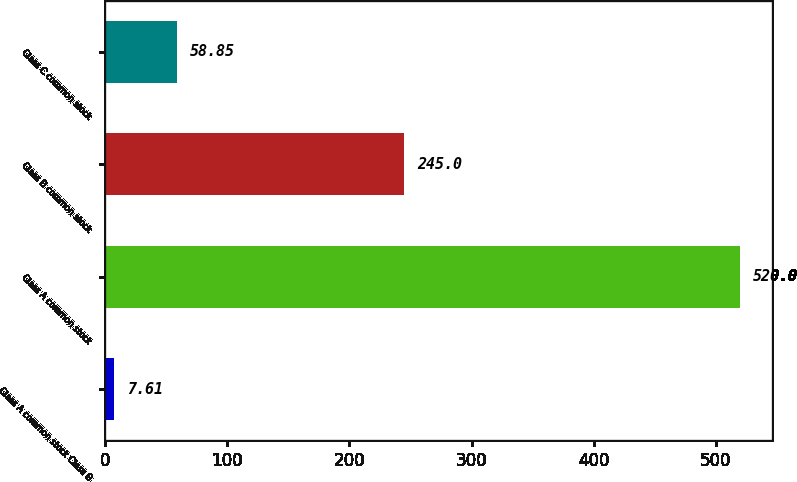Convert chart to OTSL. <chart><loc_0><loc_0><loc_500><loc_500><bar_chart><fcel>Class A common stock Class B<fcel>Class A common stock<fcel>Class B common stock<fcel>Class C common stock<nl><fcel>7.61<fcel>520<fcel>245<fcel>58.85<nl></chart> 